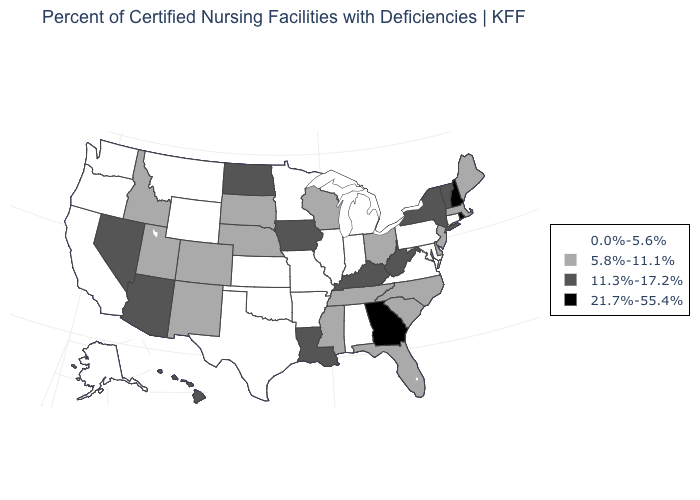Among the states that border Pennsylvania , which have the lowest value?
Answer briefly. Maryland. What is the lowest value in the USA?
Give a very brief answer. 0.0%-5.6%. What is the value of West Virginia?
Give a very brief answer. 11.3%-17.2%. Does Alaska have the same value as Minnesota?
Concise answer only. Yes. Does Vermont have the highest value in the Northeast?
Quick response, please. No. Which states have the lowest value in the USA?
Write a very short answer. Alabama, Alaska, Arkansas, California, Connecticut, Illinois, Indiana, Kansas, Maryland, Michigan, Minnesota, Missouri, Montana, Oklahoma, Oregon, Pennsylvania, Texas, Virginia, Washington, Wyoming. Name the states that have a value in the range 5.8%-11.1%?
Answer briefly. Colorado, Delaware, Florida, Idaho, Maine, Massachusetts, Mississippi, Nebraska, New Jersey, New Mexico, North Carolina, Ohio, South Carolina, South Dakota, Tennessee, Utah, Wisconsin. What is the lowest value in the USA?
Keep it brief. 0.0%-5.6%. Does the map have missing data?
Answer briefly. No. Does Colorado have a higher value than Texas?
Short answer required. Yes. Does Kentucky have the highest value in the USA?
Give a very brief answer. No. Does South Dakota have a higher value than Kentucky?
Be succinct. No. Name the states that have a value in the range 5.8%-11.1%?
Short answer required. Colorado, Delaware, Florida, Idaho, Maine, Massachusetts, Mississippi, Nebraska, New Jersey, New Mexico, North Carolina, Ohio, South Carolina, South Dakota, Tennessee, Utah, Wisconsin. Among the states that border California , which have the lowest value?
Short answer required. Oregon. Does Iowa have the lowest value in the USA?
Short answer required. No. 